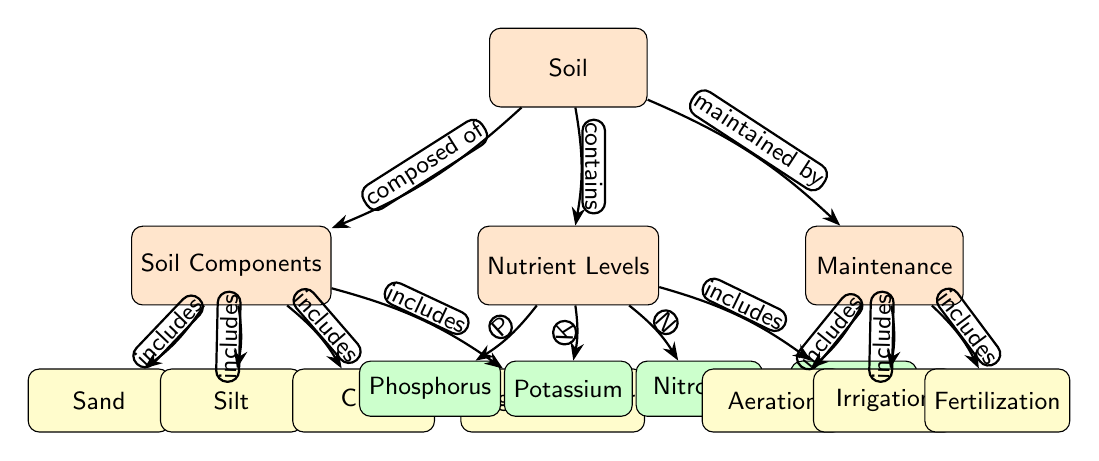What are the components of soil? The diagram identifies four components of soil that are directly connected to the "Soil Components" node: Sand, Silt, Clay, and Organic Matter.
Answer: Sand, Silt, Clay, Organic Matter Which nutrient has the symbol N? Referring to the "Nutrient Levels" node, Nitrogen is specified to have the symbol N.
Answer: Nitrogen What type of maintenance includes aeration? The "Maintenance" node connects to Aeration, indicating it is one of the included maintenance activities.
Answer: Aeration How many main nodes are present in the diagram? By counting the main nodes, we see there are three: "Soil," "Nutrient Levels," and "Maintenance." Therefore, the total count of main nodes is three.
Answer: 3 What does soil contain according to the diagram? The "Soil" node connects to the "Nutrient Levels" node, indicating that soil contains several nutrients, specifically listed as Phosphorus, Potassium, Nitrogen, and pH Level.
Answer: Nutrient Levels Which maintenance activity is related to fertilization? Fertilization is one of the activities listed under the "Maintenance" node, indicating that it is directly related to soil maintenance efforts.
Answer: Fertilization What is included in the nutrient levels category? The "Nutrient Levels" node shows that it includes four specific nutrients: Phosphorus, Potassium, Nitrogen, and pH Level.
Answer: Phosphorus, Potassium, Nitrogen, pH Level Which component of the soil diagram deals with moisture management? Irrigation is a specific maintenance activity listed under the "Maintenance" node, indicating its role in managing moisture in the soil.
Answer: Irrigation What relationship does soil have with maintenance? The "Soil" node is maintained by the "Maintenance" node according to the directional relationship indicated in the diagram.
Answer: Maintained by 